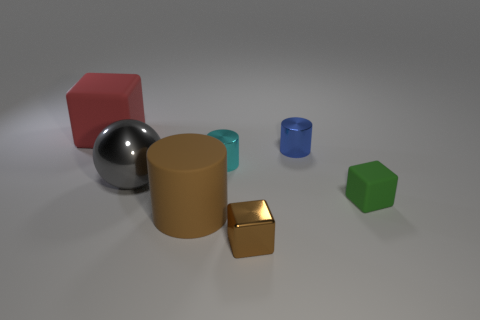Are the green object and the large red cube made of the same material?
Provide a short and direct response. Yes. There is a brown object that is made of the same material as the large ball; what shape is it?
Offer a terse response. Cube. Is the number of metallic balls less than the number of small yellow rubber things?
Keep it short and to the point. No. There is a cube that is to the left of the small green rubber cube and in front of the gray shiny object; what material is it?
Your response must be concise. Metal. What is the size of the matte cube in front of the large rubber object that is behind the matte block that is in front of the big rubber cube?
Provide a succinct answer. Small. There is a cyan metal object; is it the same shape as the metal object in front of the big brown matte cylinder?
Give a very brief answer. No. How many things are both in front of the blue cylinder and behind the small green cube?
Offer a very short reply. 2. What number of green things are large matte cylinders or tiny metal things?
Ensure brevity in your answer.  0. There is a cube that is in front of the matte cylinder; is it the same color as the big matte object that is on the right side of the red matte thing?
Ensure brevity in your answer.  Yes. There is a large matte thing in front of the tiny cylinder on the left side of the object in front of the big brown matte object; what color is it?
Offer a very short reply. Brown. 